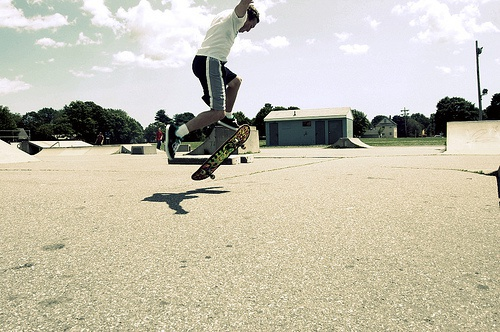Describe the objects in this image and their specific colors. I can see people in lavender, black, darkgray, gray, and white tones, skateboard in lavender, black, darkgreen, gray, and olive tones, people in lavender, black, maroon, brown, and gray tones, and people in lavender, black, and gray tones in this image. 